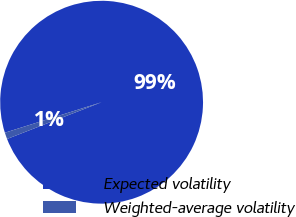<chart> <loc_0><loc_0><loc_500><loc_500><pie_chart><fcel>Expected volatility<fcel>Weighted-average volatility<nl><fcel>98.96%<fcel>1.04%<nl></chart> 